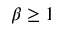<formula> <loc_0><loc_0><loc_500><loc_500>\beta \geq 1</formula> 